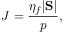<formula> <loc_0><loc_0><loc_500><loc_500>J = \frac { \eta _ { f } | S | } { p } ,</formula> 